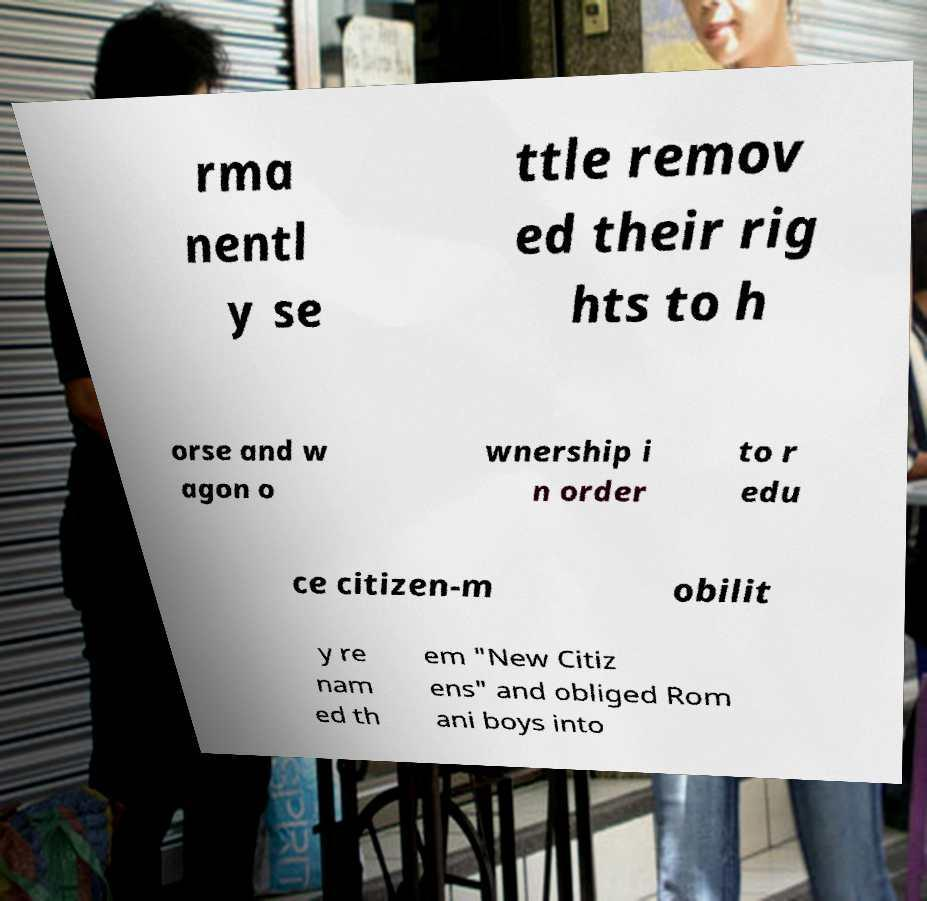Please identify and transcribe the text found in this image. rma nentl y se ttle remov ed their rig hts to h orse and w agon o wnership i n order to r edu ce citizen-m obilit y re nam ed th em "New Citiz ens" and obliged Rom ani boys into 